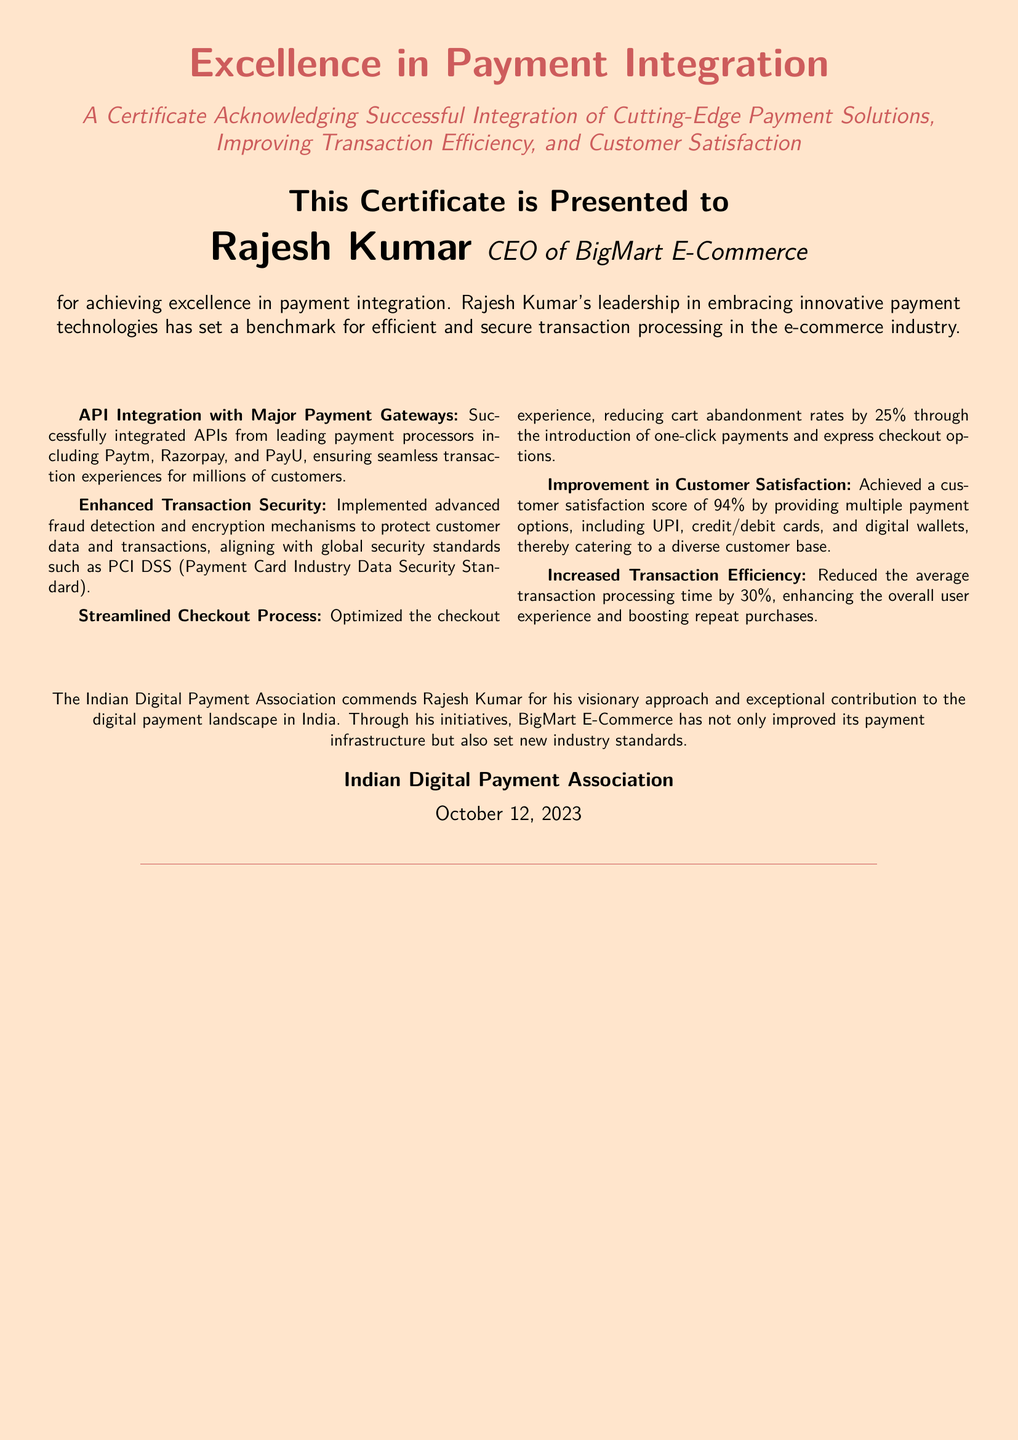What is the title of the certificate? The title of the certificate is prominent and declares the achievement being acknowledged.
Answer: Excellence in Payment Integration Who is the recipient of the certificate? The certificate specifically awards a recipient for their achievements in a particular field.
Answer: Rajesh Kumar What is the organization that issued the certificate? The document mentions the issuing organization at the bottom, providing credibility to the certificate.
Answer: Indian Digital Payment Association On what date was the certificate issued? The date of issuance is located towards the end of the certificate.
Answer: October 12, 2023 What percentage reduction in cart abandonment rates was achieved? The document specifies the impact of the optimized checkout experience on cart abandonment rates.
Answer: 25% Which technologies were integrated for improved payment processing? The achievements listed specify the payment processing integrations made by the recipient.
Answer: Paytm, Razorpay, and PayU What is the customer satisfaction score mentioned? The certificate highlights a specific measure of customer feedback on service quality.
Answer: 94% What was the average transaction processing time reduction? The document quantifies the efficiency improvements in transaction processing times.
Answer: 30% What security standard is mentioned in relation to the improvements made? The document refers to a well-known security framework applicable to payment data protection.
Answer: PCI DSS 